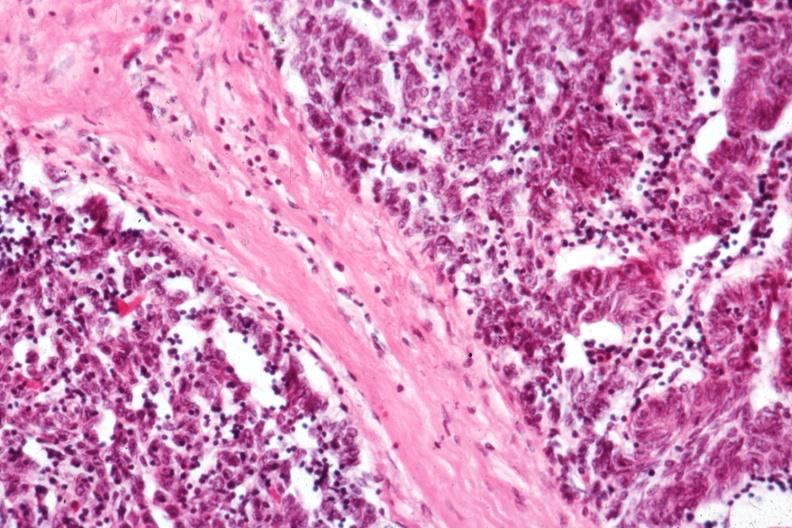s intestine present?
Answer the question using a single word or phrase. No 